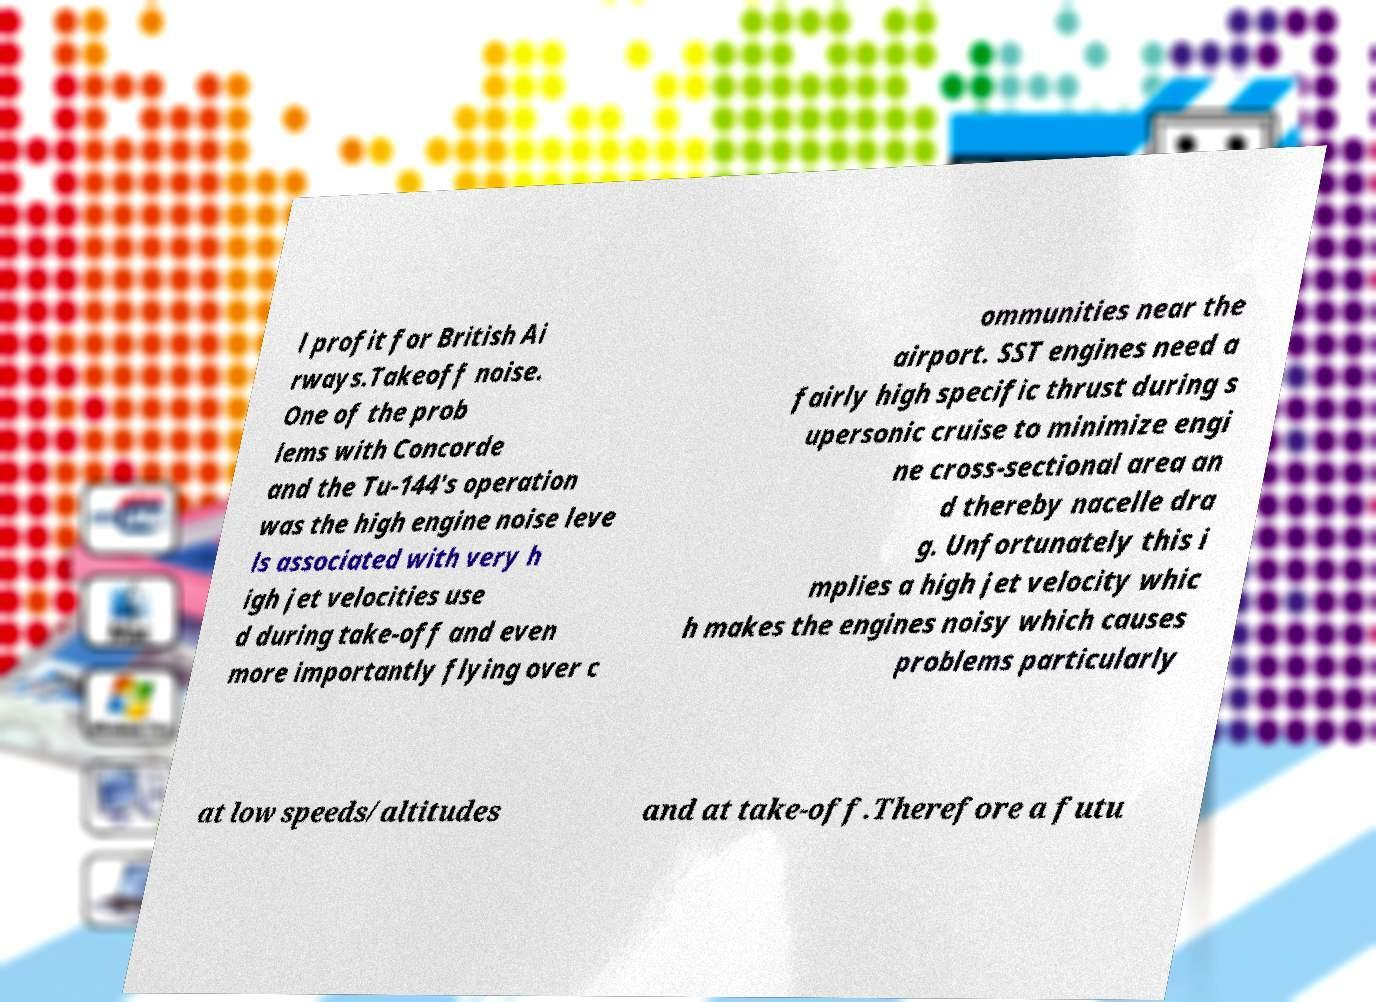What messages or text are displayed in this image? I need them in a readable, typed format. l profit for British Ai rways.Takeoff noise. One of the prob lems with Concorde and the Tu-144's operation was the high engine noise leve ls associated with very h igh jet velocities use d during take-off and even more importantly flying over c ommunities near the airport. SST engines need a fairly high specific thrust during s upersonic cruise to minimize engi ne cross-sectional area an d thereby nacelle dra g. Unfortunately this i mplies a high jet velocity whic h makes the engines noisy which causes problems particularly at low speeds/altitudes and at take-off.Therefore a futu 